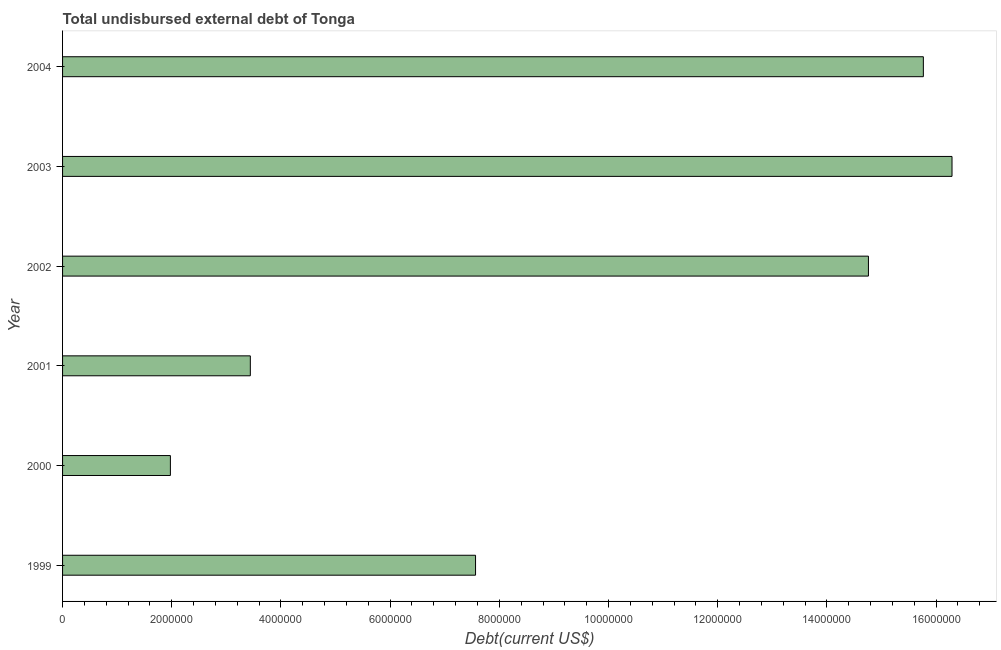Does the graph contain grids?
Give a very brief answer. No. What is the title of the graph?
Your answer should be compact. Total undisbursed external debt of Tonga. What is the label or title of the X-axis?
Keep it short and to the point. Debt(current US$). What is the label or title of the Y-axis?
Provide a short and direct response. Year. What is the total debt in 2002?
Provide a short and direct response. 1.48e+07. Across all years, what is the maximum total debt?
Give a very brief answer. 1.63e+07. Across all years, what is the minimum total debt?
Offer a terse response. 1.98e+06. In which year was the total debt minimum?
Give a very brief answer. 2000. What is the sum of the total debt?
Your response must be concise. 5.98e+07. What is the difference between the total debt in 2000 and 2004?
Make the answer very short. -1.38e+07. What is the average total debt per year?
Your answer should be compact. 9.97e+06. What is the median total debt?
Your answer should be very brief. 1.12e+07. What is the ratio of the total debt in 1999 to that in 2002?
Your answer should be very brief. 0.51. Is the total debt in 1999 less than that in 2000?
Your answer should be compact. No. Is the difference between the total debt in 2003 and 2004 greater than the difference between any two years?
Provide a succinct answer. No. What is the difference between the highest and the second highest total debt?
Your answer should be compact. 5.25e+05. What is the difference between the highest and the lowest total debt?
Your answer should be compact. 1.43e+07. How many bars are there?
Your answer should be compact. 6. Are all the bars in the graph horizontal?
Offer a very short reply. Yes. What is the Debt(current US$) of 1999?
Keep it short and to the point. 7.56e+06. What is the Debt(current US$) in 2000?
Give a very brief answer. 1.98e+06. What is the Debt(current US$) of 2001?
Give a very brief answer. 3.44e+06. What is the Debt(current US$) in 2002?
Offer a terse response. 1.48e+07. What is the Debt(current US$) in 2003?
Keep it short and to the point. 1.63e+07. What is the Debt(current US$) in 2004?
Make the answer very short. 1.58e+07. What is the difference between the Debt(current US$) in 1999 and 2000?
Provide a short and direct response. 5.59e+06. What is the difference between the Debt(current US$) in 1999 and 2001?
Keep it short and to the point. 4.12e+06. What is the difference between the Debt(current US$) in 1999 and 2002?
Ensure brevity in your answer.  -7.20e+06. What is the difference between the Debt(current US$) in 1999 and 2003?
Your answer should be very brief. -8.73e+06. What is the difference between the Debt(current US$) in 1999 and 2004?
Make the answer very short. -8.20e+06. What is the difference between the Debt(current US$) in 2000 and 2001?
Give a very brief answer. -1.46e+06. What is the difference between the Debt(current US$) in 2000 and 2002?
Ensure brevity in your answer.  -1.28e+07. What is the difference between the Debt(current US$) in 2000 and 2003?
Keep it short and to the point. -1.43e+07. What is the difference between the Debt(current US$) in 2000 and 2004?
Offer a very short reply. -1.38e+07. What is the difference between the Debt(current US$) in 2001 and 2002?
Offer a terse response. -1.13e+07. What is the difference between the Debt(current US$) in 2001 and 2003?
Offer a terse response. -1.29e+07. What is the difference between the Debt(current US$) in 2001 and 2004?
Provide a short and direct response. -1.23e+07. What is the difference between the Debt(current US$) in 2002 and 2003?
Provide a short and direct response. -1.53e+06. What is the difference between the Debt(current US$) in 2002 and 2004?
Make the answer very short. -1.01e+06. What is the difference between the Debt(current US$) in 2003 and 2004?
Your answer should be very brief. 5.25e+05. What is the ratio of the Debt(current US$) in 1999 to that in 2000?
Offer a terse response. 3.83. What is the ratio of the Debt(current US$) in 1999 to that in 2001?
Offer a very short reply. 2.2. What is the ratio of the Debt(current US$) in 1999 to that in 2002?
Give a very brief answer. 0.51. What is the ratio of the Debt(current US$) in 1999 to that in 2003?
Provide a short and direct response. 0.46. What is the ratio of the Debt(current US$) in 1999 to that in 2004?
Your answer should be compact. 0.48. What is the ratio of the Debt(current US$) in 2000 to that in 2001?
Your answer should be very brief. 0.57. What is the ratio of the Debt(current US$) in 2000 to that in 2002?
Provide a short and direct response. 0.13. What is the ratio of the Debt(current US$) in 2000 to that in 2003?
Provide a succinct answer. 0.12. What is the ratio of the Debt(current US$) in 2000 to that in 2004?
Give a very brief answer. 0.12. What is the ratio of the Debt(current US$) in 2001 to that in 2002?
Your response must be concise. 0.23. What is the ratio of the Debt(current US$) in 2001 to that in 2003?
Your response must be concise. 0.21. What is the ratio of the Debt(current US$) in 2001 to that in 2004?
Your response must be concise. 0.22. What is the ratio of the Debt(current US$) in 2002 to that in 2003?
Your answer should be compact. 0.91. What is the ratio of the Debt(current US$) in 2002 to that in 2004?
Provide a succinct answer. 0.94. What is the ratio of the Debt(current US$) in 2003 to that in 2004?
Your response must be concise. 1.03. 